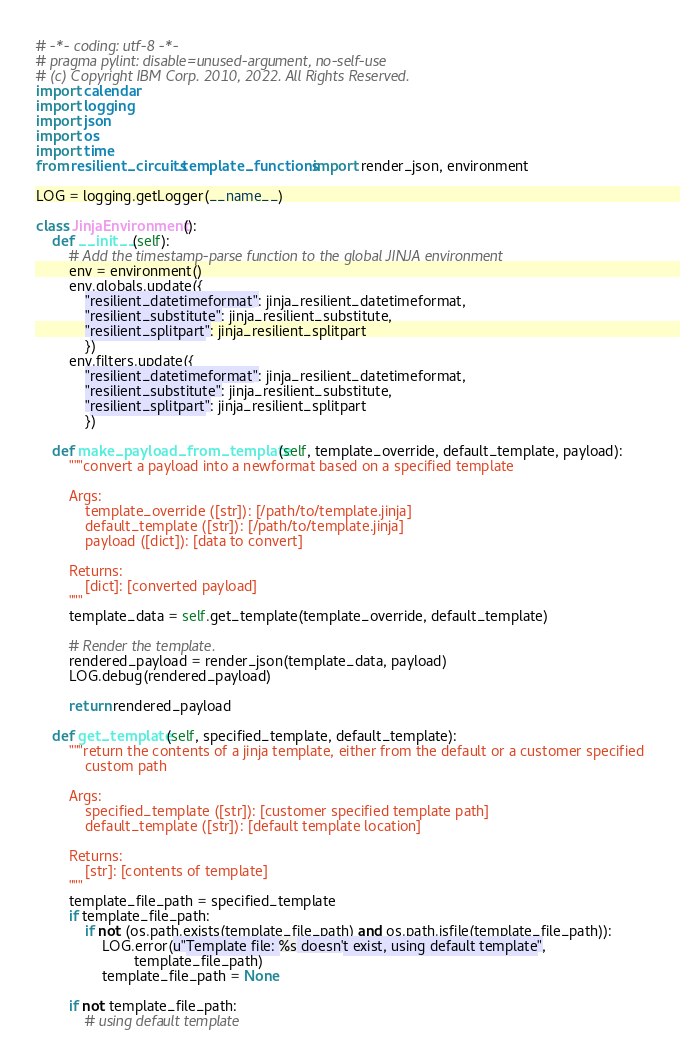Convert code to text. <code><loc_0><loc_0><loc_500><loc_500><_Python_># -*- coding: utf-8 -*-
# pragma pylint: disable=unused-argument, no-self-use
# (c) Copyright IBM Corp. 2010, 2022. All Rights Reserved.
import calendar
import logging
import json
import os
import time
from resilient_circuits.template_functions import render_json, environment

LOG = logging.getLogger(__name__)

class JinjaEnvironment():
    def __init__(self):
        # Add the timestamp-parse function to the global JINJA environment
        env = environment()
        env.globals.update({
            "resilient_datetimeformat": jinja_resilient_datetimeformat,
            "resilient_substitute": jinja_resilient_substitute,
            "resilient_splitpart": jinja_resilient_splitpart
            })
        env.filters.update({
            "resilient_datetimeformat": jinja_resilient_datetimeformat,
            "resilient_substitute": jinja_resilient_substitute,
            "resilient_splitpart": jinja_resilient_splitpart
            })

    def make_payload_from_template(self, template_override, default_template, payload):
        """convert a payload into a newformat based on a specified template

        Args:
            template_override ([str]): [/path/to/template.jinja]
            default_template ([str]): [/path/to/template.jinja]
            payload ([dict]): [data to convert]

        Returns:
            [dict]: [converted payload]
        """
        template_data = self.get_template(template_override, default_template)

        # Render the template.
        rendered_payload = render_json(template_data, payload)
        LOG.debug(rendered_payload)

        return rendered_payload

    def get_template(self, specified_template, default_template):
        """return the contents of a jinja template, either from the default or a customer specified
            custom path

        Args:
            specified_template ([str]): [customer specified template path]
            default_template ([str]): [default template location]

        Returns:
            [str]: [contents of template]
        """
        template_file_path = specified_template
        if template_file_path:
            if not (os.path.exists(template_file_path) and os.path.isfile(template_file_path)):
                LOG.error(u"Template file: %s doesn't exist, using default template",
                        template_file_path)
                template_file_path = None

        if not template_file_path:
            # using default template</code> 